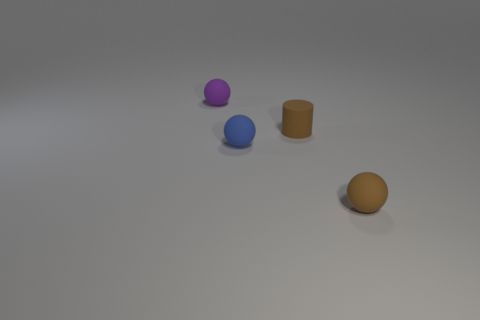There is a tiny cylinder that is made of the same material as the blue thing; what is its color?
Your response must be concise. Brown. How many brown objects have the same material as the brown cylinder?
Provide a short and direct response. 1. How many small blue rubber objects are there?
Provide a short and direct response. 1. There is a tiny object in front of the blue thing; does it have the same color as the cylinder behind the tiny blue matte object?
Provide a succinct answer. Yes. There is a cylinder; how many cylinders are to the right of it?
Provide a succinct answer. 0. There is a small object that is the same color as the small cylinder; what is its material?
Your answer should be compact. Rubber. Is there another object of the same shape as the tiny purple rubber object?
Ensure brevity in your answer.  Yes. There is a cylinder that is the same size as the purple thing; what is it made of?
Ensure brevity in your answer.  Rubber. Are there any blue matte balls that have the same size as the brown rubber sphere?
Give a very brief answer. Yes. Does the tiny blue matte thing have the same shape as the small purple object?
Offer a terse response. Yes. 